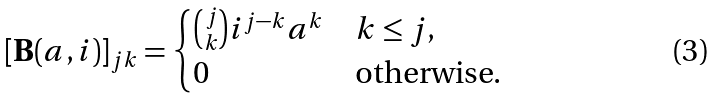Convert formula to latex. <formula><loc_0><loc_0><loc_500><loc_500>[ \mathbf B ( a , i ) ] _ { j k } = \begin{cases} \binom { j } { k } i ^ { j - k } a ^ { k } & k \leq j , \\ 0 & \text {otherwise.} \end{cases}</formula> 